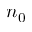Convert formula to latex. <formula><loc_0><loc_0><loc_500><loc_500>n _ { 0 }</formula> 